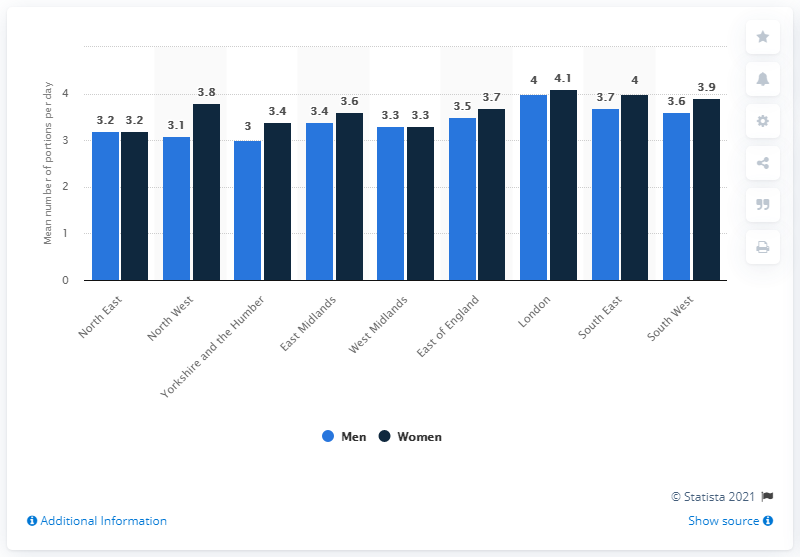Mention a couple of crucial points in this snapshot. In 2013, men in the South East of England consumed an average of 3.7 portions of fruit and vegetables per day, according to a recent study. 